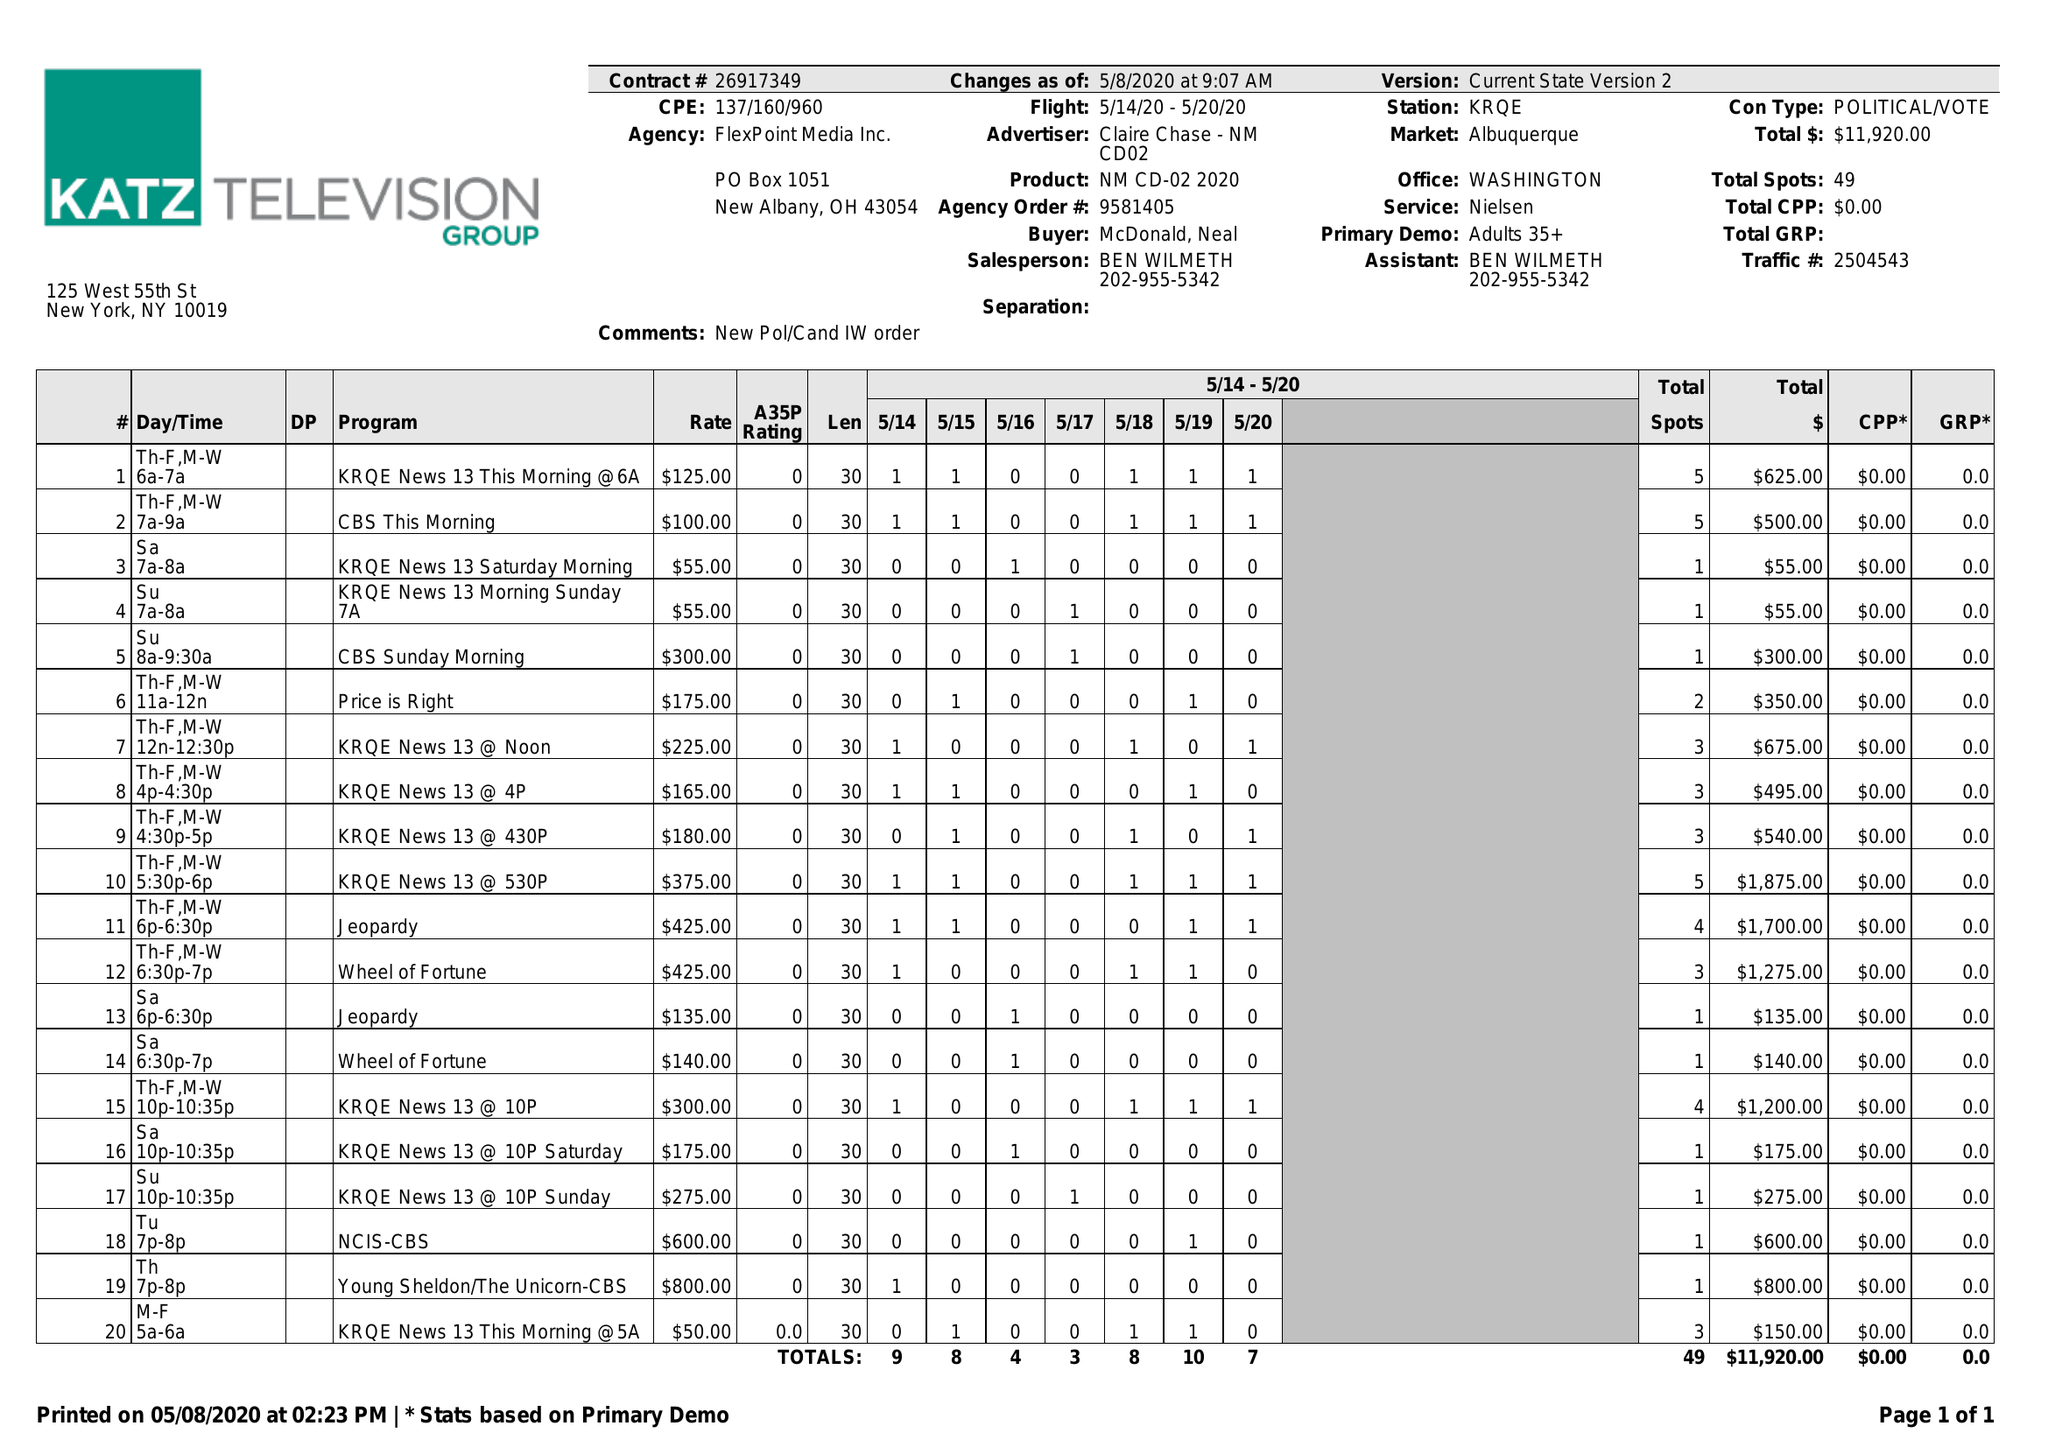What is the value for the flight_to?
Answer the question using a single word or phrase. 05/20/20 